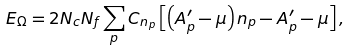Convert formula to latex. <formula><loc_0><loc_0><loc_500><loc_500>E _ { \Omega } = 2 N _ { c } N _ { f } \sum _ { p } C _ { n _ { p } } \left [ \left ( A ^ { \prime } _ { p } - \mu \right ) n _ { p } - A ^ { \prime } _ { p } - \mu \right ] ,</formula> 